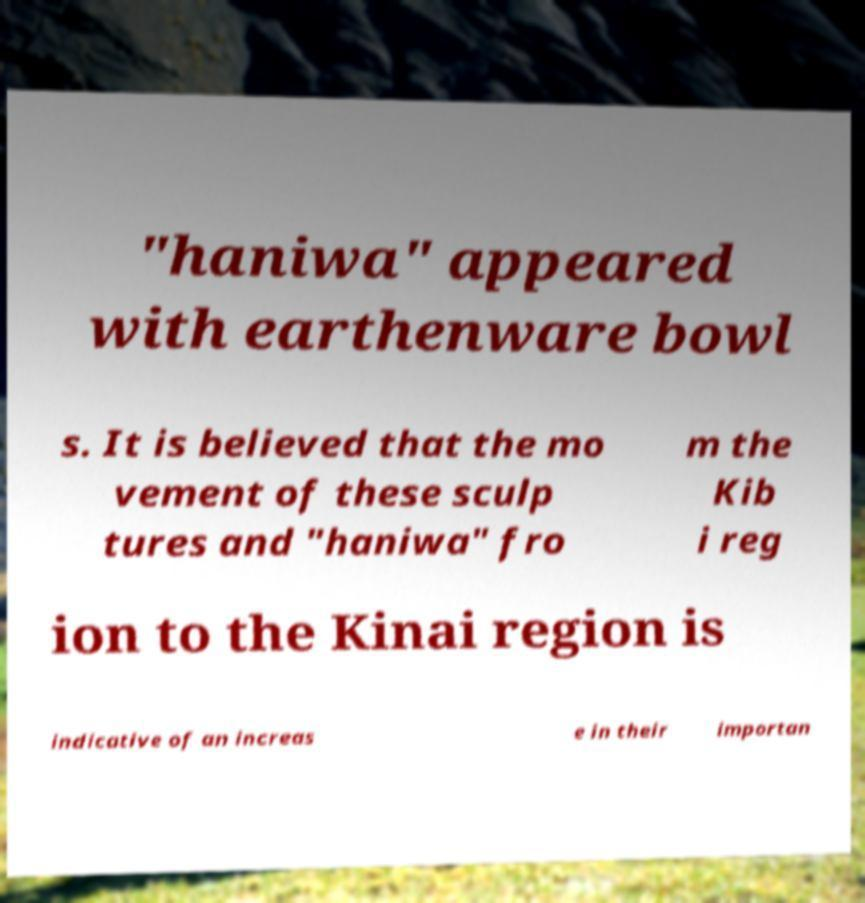I need the written content from this picture converted into text. Can you do that? "haniwa" appeared with earthenware bowl s. It is believed that the mo vement of these sculp tures and "haniwa" fro m the Kib i reg ion to the Kinai region is indicative of an increas e in their importan 